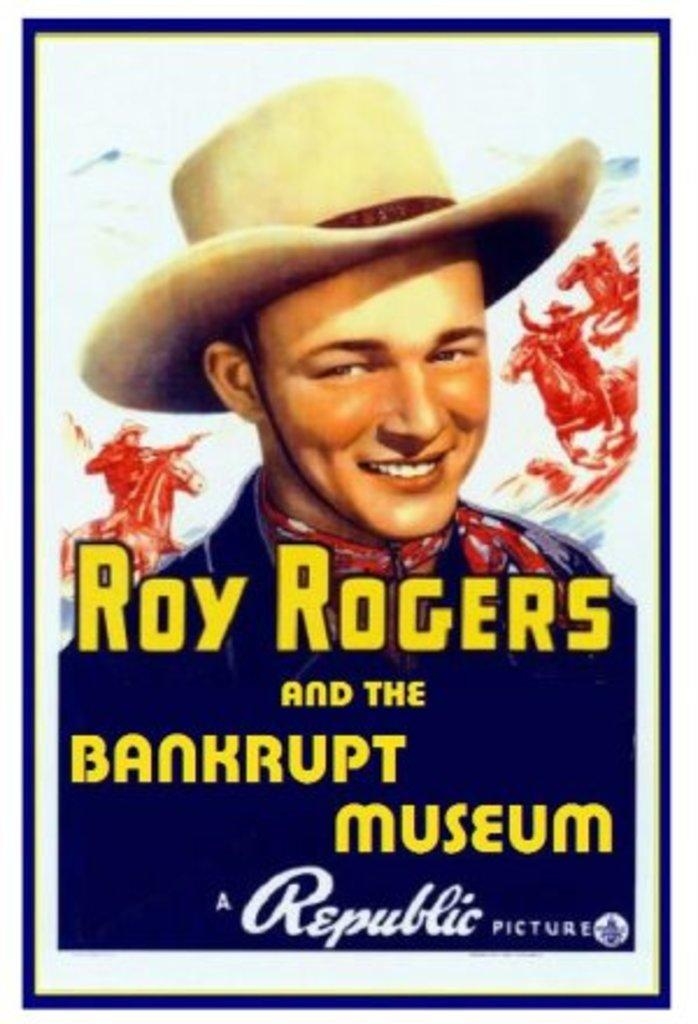<image>
Offer a succinct explanation of the picture presented. A movie poster advertises a flick called Roy Rogers and the Bankrupt Museum. 